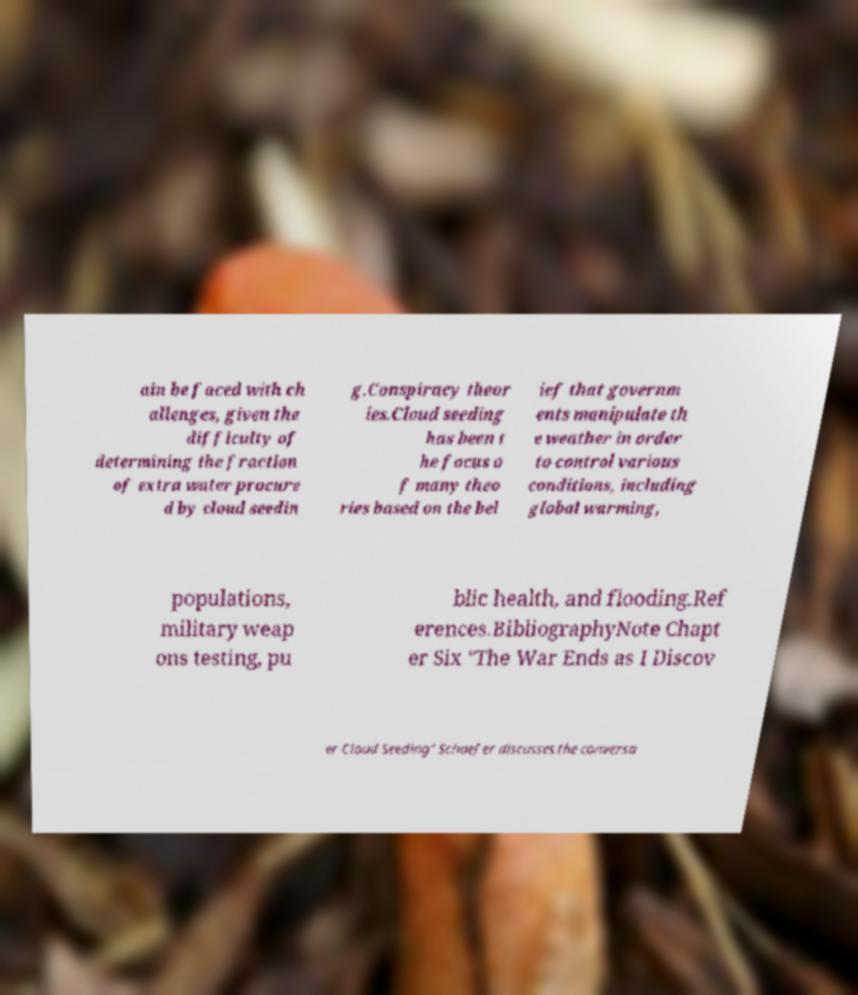Please identify and transcribe the text found in this image. ain be faced with ch allenges, given the difficulty of determining the fraction of extra water procure d by cloud seedin g.Conspiracy theor ies.Cloud seeding has been t he focus o f many theo ries based on the bel ief that governm ents manipulate th e weather in order to control various conditions, including global warming, populations, military weap ons testing, pu blic health, and flooding.Ref erences.BibliographyNote Chapt er Six "The War Ends as I Discov er Cloud Seeding" Schaefer discusses the conversa 